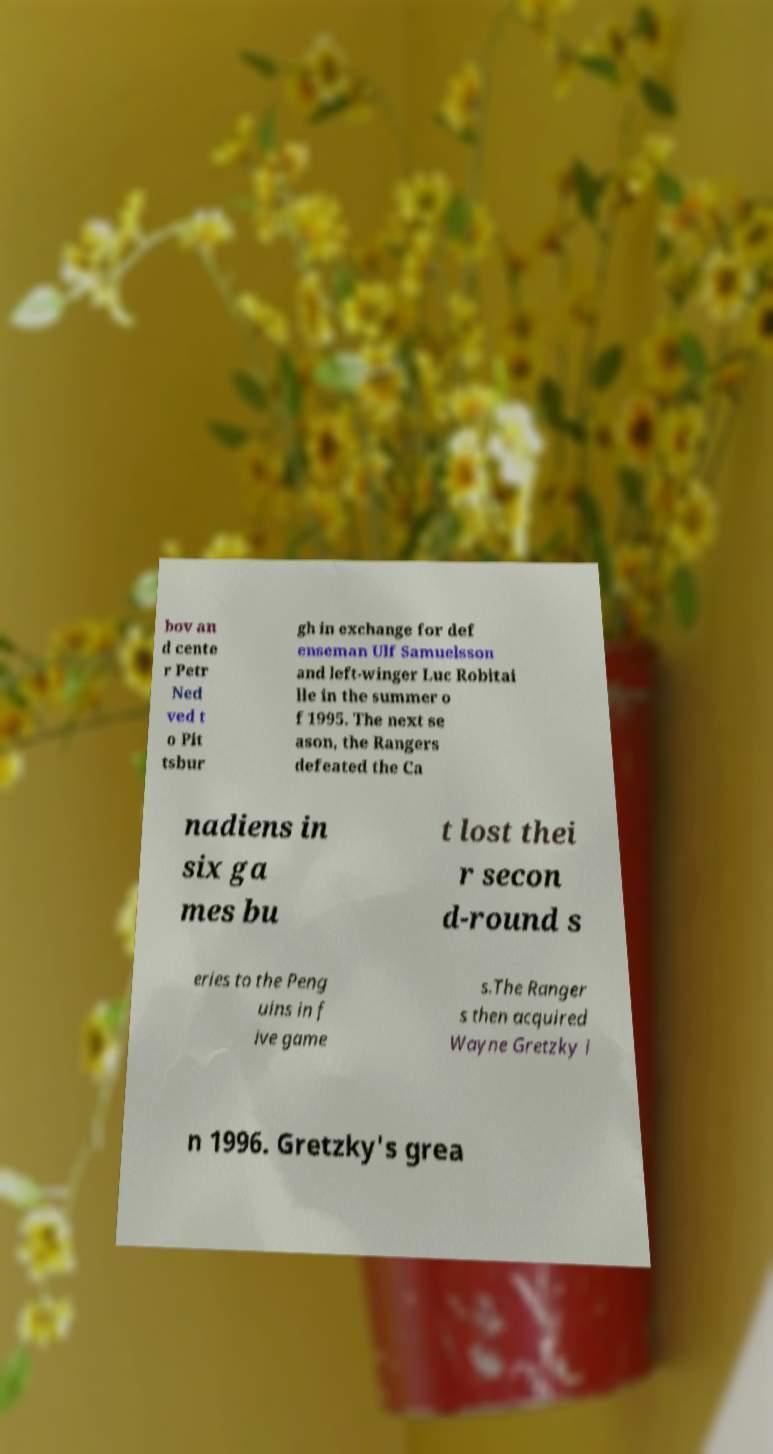Please read and relay the text visible in this image. What does it say? bov an d cente r Petr Ned ved t o Pit tsbur gh in exchange for def enseman Ulf Samuelsson and left-winger Luc Robitai lle in the summer o f 1995. The next se ason, the Rangers defeated the Ca nadiens in six ga mes bu t lost thei r secon d-round s eries to the Peng uins in f ive game s.The Ranger s then acquired Wayne Gretzky i n 1996. Gretzky's grea 